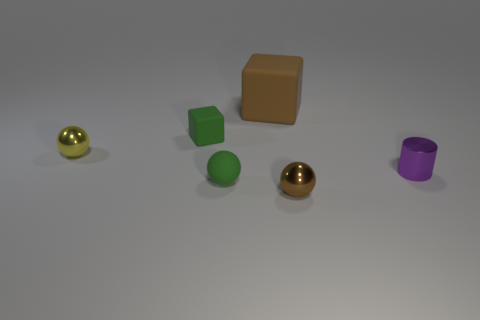Add 2 purple cylinders. How many objects exist? 8 Subtract all cylinders. How many objects are left? 5 Subtract all cyan metal cylinders. Subtract all big brown matte things. How many objects are left? 5 Add 4 cylinders. How many cylinders are left? 5 Add 6 small green metallic things. How many small green metallic things exist? 6 Subtract 0 blue spheres. How many objects are left? 6 